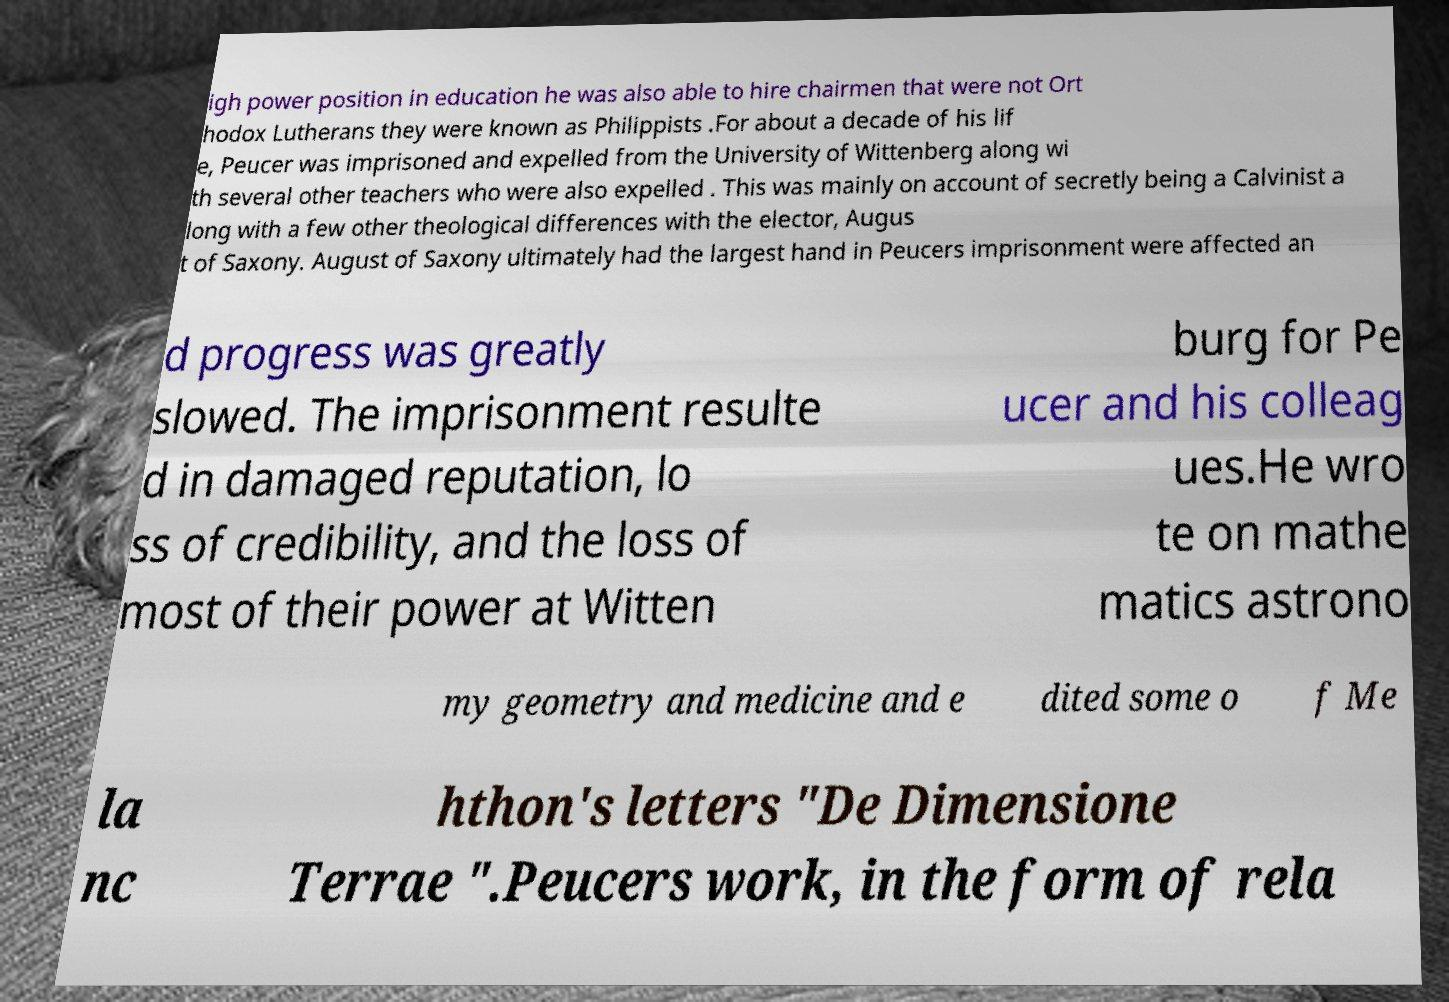Could you extract and type out the text from this image? igh power position in education he was also able to hire chairmen that were not Ort hodox Lutherans they were known as Philippists .For about a decade of his lif e, Peucer was imprisoned and expelled from the University of Wittenberg along wi th several other teachers who were also expelled . This was mainly on account of secretly being a Calvinist a long with a few other theological differences with the elector, Augus t of Saxony. August of Saxony ultimately had the largest hand in Peucers imprisonment were affected an d progress was greatly slowed. The imprisonment resulte d in damaged reputation, lo ss of credibility, and the loss of most of their power at Witten burg for Pe ucer and his colleag ues.He wro te on mathe matics astrono my geometry and medicine and e dited some o f Me la nc hthon's letters "De Dimensione Terrae ".Peucers work, in the form of rela 